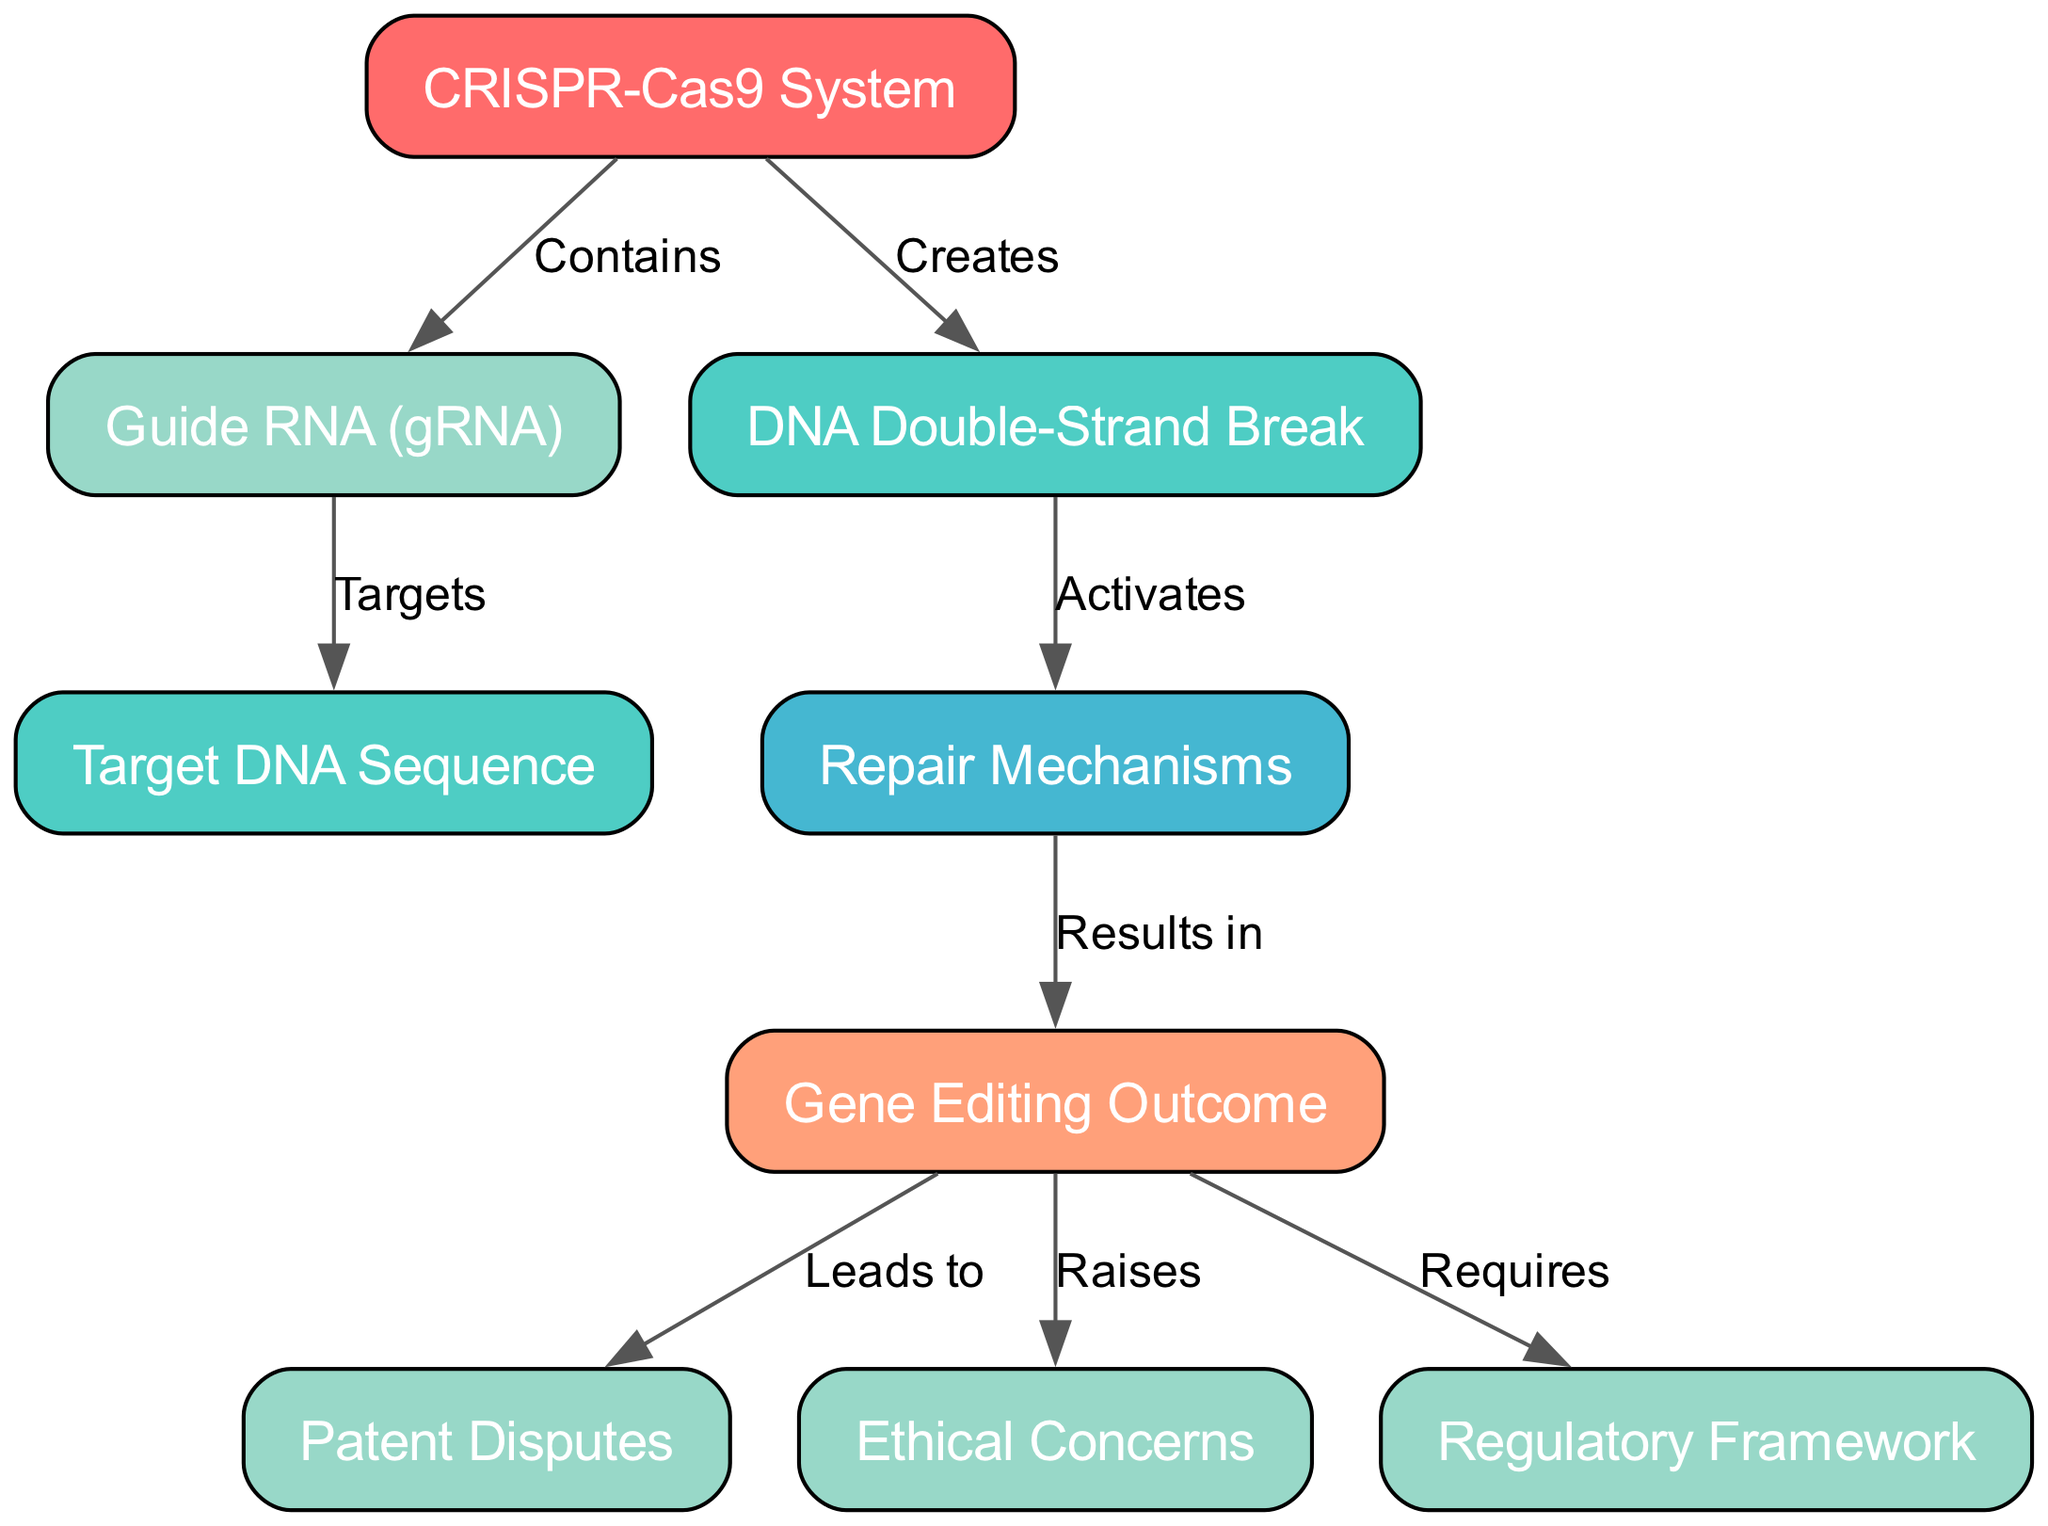What is the label of node 1? Node 1 corresponds to the CRISPR system, which is noted in the diagram under the label.
Answer: CRISPR-Cas9 System How many nodes are there in the diagram? By counting the number of distinct entities represented in the diagram, we find there are 9 nodes listed.
Answer: 9 What relationship does the guide RNA have with the target DNA sequence? The diagram illustrates that the guide RNA (node 2) targets the target DNA sequence (node 3), showing a direct connection between these two nodes.
Answer: Targets Which node leads to patent disputes? According to the diagram, the gene editing outcome (node 6) is indicated to lead to patent disputes (node 7), establishing a cause-and-effect relationship.
Answer: Gene Editing Outcome What is connected to the DNA double-strand break? The edges show that the DNA double-strand break (node 4) activates the repair mechanisms (node 5), making this the direct connection.
Answer: Repair Mechanisms What ethical issues arise from the gene editing outcome? The diagram indicates that the gene editing outcome (node 6) raises ethical concerns (node 8), establishing a relationship where potential ethical implications arise from the outcomes of gene editing.
Answer: Ethical Concerns How does the CRISPR-Cas9 system affect the DNA structure? The CRISPR-Cas9 system (node 1) creates a DNA double-strand break (node 4) as a result of its mechanism, showing it directly impacts the structure of DNA.
Answer: Creates What do repair mechanisms result in? The repair mechanisms (node 5) in the diagram are shown to result in the gene editing outcome (node 6), indicating a consequential flow from the mechanisms to the final outcome.
Answer: Gene Editing Outcome What must be established due to the gene editing outcomes? The diagram specifies that the gene editing outcome (node 6) requires a regulatory framework (node 9), suggesting that legal oversight is necessary for managing the implications of such outcomes.
Answer: Regulatory Framework 